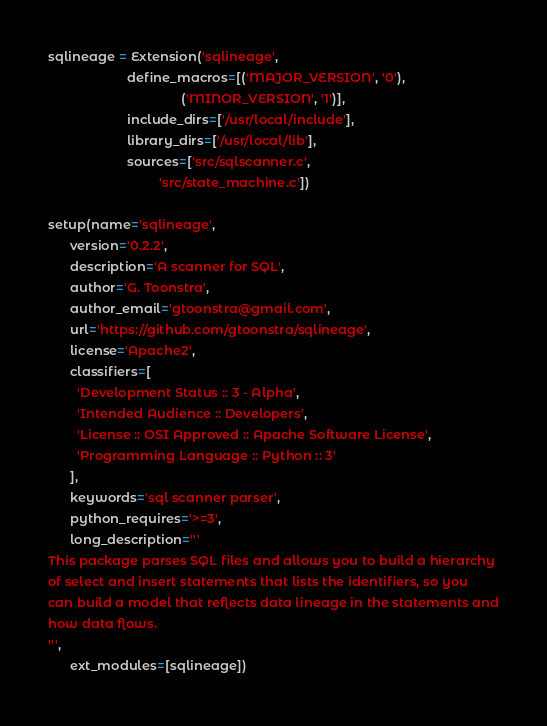<code> <loc_0><loc_0><loc_500><loc_500><_Python_>sqlineage = Extension('sqlineage',
                      define_macros=[('MAJOR_VERSION', '0'),
                                     ('MINOR_VERSION', '1')],
                      include_dirs=['/usr/local/include'],
                      library_dirs=['/usr/local/lib'],
                      sources=['src/sqlscanner.c', 
                               'src/state_machine.c'])

setup(name='sqlineage',
      version='0.2.2',
      description='A scanner for SQL',
      author='G. Toonstra',
      author_email='gtoonstra@gmail.com',
      url='https://github.com/gtoonstra/sqlineage',
      license='Apache2',
      classifiers=[
        'Development Status :: 3 - Alpha',
        'Intended Audience :: Developers',
        'License :: OSI Approved :: Apache Software License',
        'Programming Language :: Python :: 3'
      ],
      keywords='sql scanner parser',
      python_requires='>=3',
      long_description='''
This package parses SQL files and allows you to build a hierarchy
of select and insert statements that lists the identifiers, so you
can build a model that reflects data lineage in the statements and
how data flows.
''',
      ext_modules=[sqlineage])
</code> 